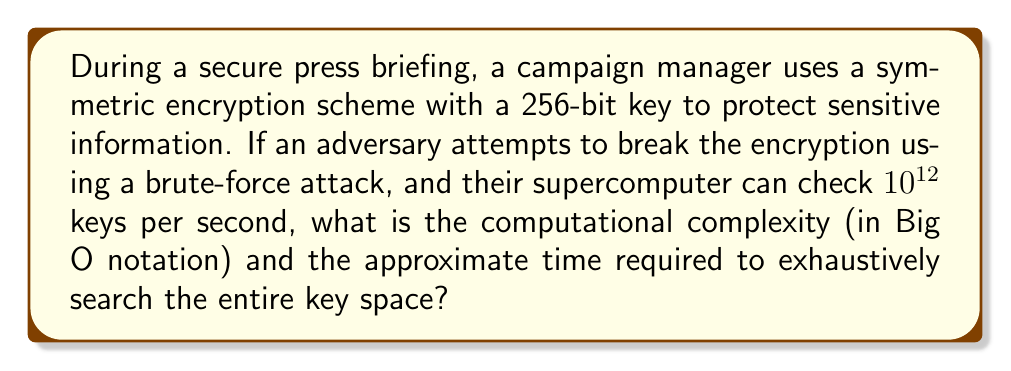What is the answer to this math problem? Let's approach this step-by-step:

1) First, we need to calculate the size of the key space:
   For a 256-bit key, there are $2^{256}$ possible keys.

2) The computational complexity of a brute-force attack is directly proportional to the size of the key space. Therefore, the complexity is $O(2^n)$, where n is the number of bits in the key. In this case, it's $O(2^{256})$.

3) To calculate the time required:
   - Total number of keys: $2^{256}$
   - Keys checked per second: $10^{12}$

4) Time required = $\frac{\text{Total number of keys}}{\text{Keys checked per second}}$

   $$ T = \frac{2^{256}}{10^{12}} \text{ seconds} $$

5) Let's convert this to years:
   $$ T = \frac{2^{256}}{10^{12} \times 60 \times 60 \times 24 \times 365.25} \text{ years} $$

6) Simplifying:
   $$ T \approx 1.8 \times 10^{58} \text{ years} $$

This time is astronomically large, far exceeding the age of the universe (approximately $13.8 \times 10^9$ years).
Answer: $O(2^{256})$; $\approx 1.8 \times 10^{58}$ years 